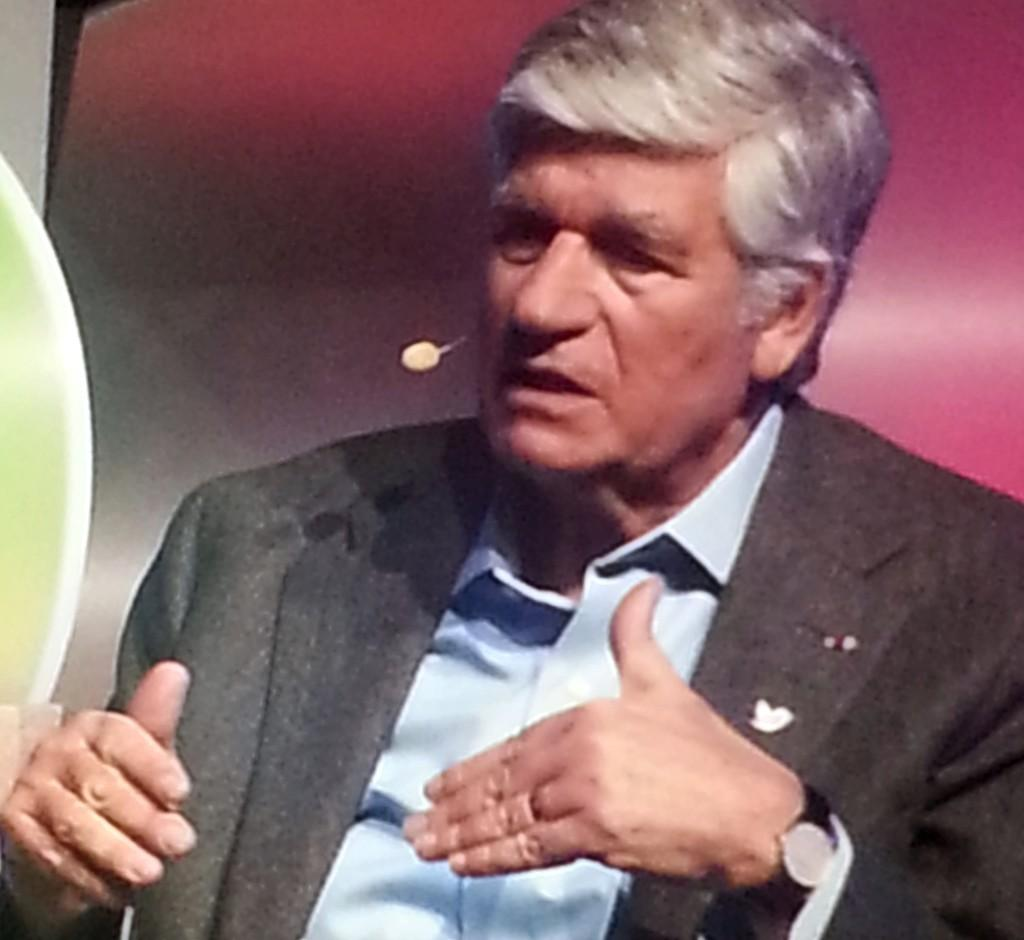What is the main subject of the image? There is a person in the center of the image. Can you describe the person's attire? The person is wearing a watch. What type of canvas is visible in the background of the image? There is no canvas present in the image. What railway is the person standing on in the image? There is no railway present in the image. 